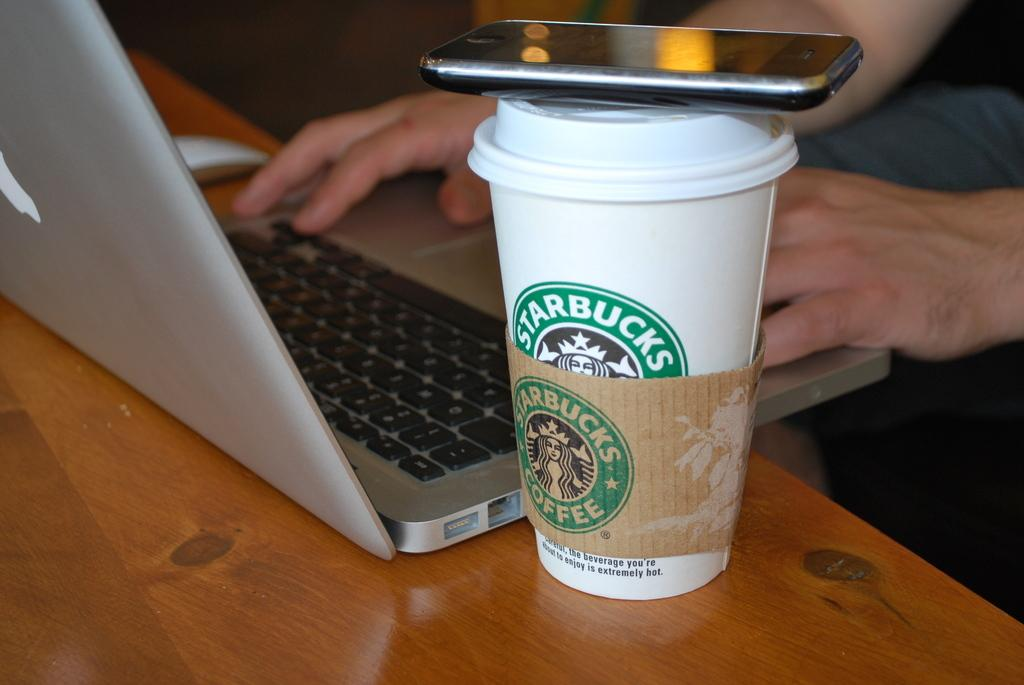Provide a one-sentence caption for the provided image. someone using laptop with a phone on top of a starbucks cup next to it. 